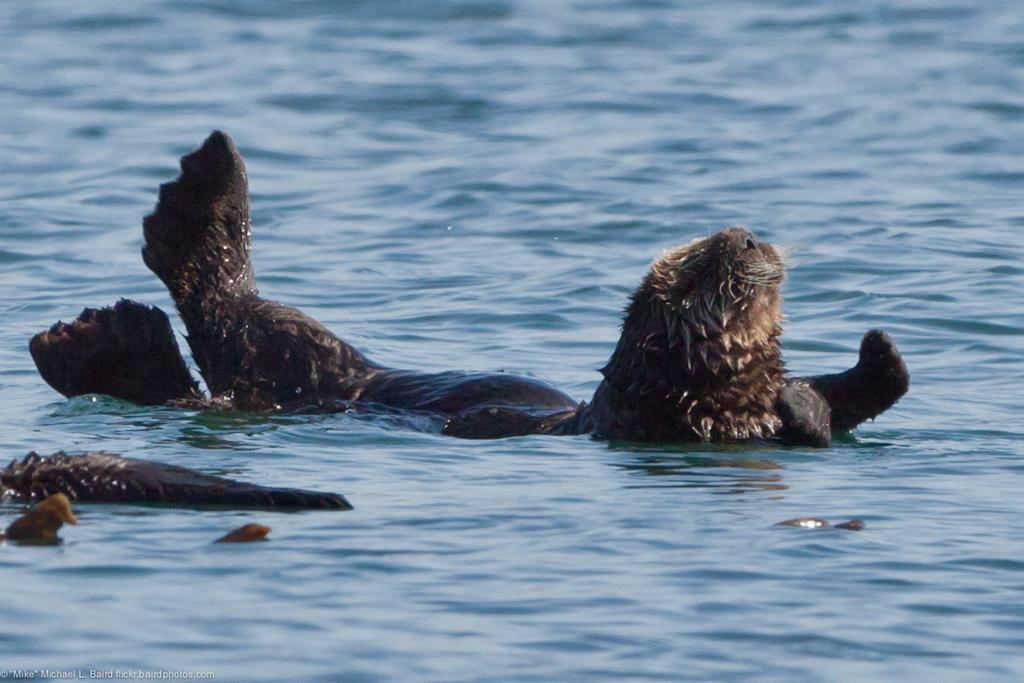What type of animal can be seen in the image? There is an aquatic animal in the image. What color is the aquatic animal? The animal is in brown color. What color is the water in the image? The water in the image is in blue color. What type of crate is being used to transport the team in the image? There is no crate or team present in the image; it features an aquatic animal in brown color and blue water. 